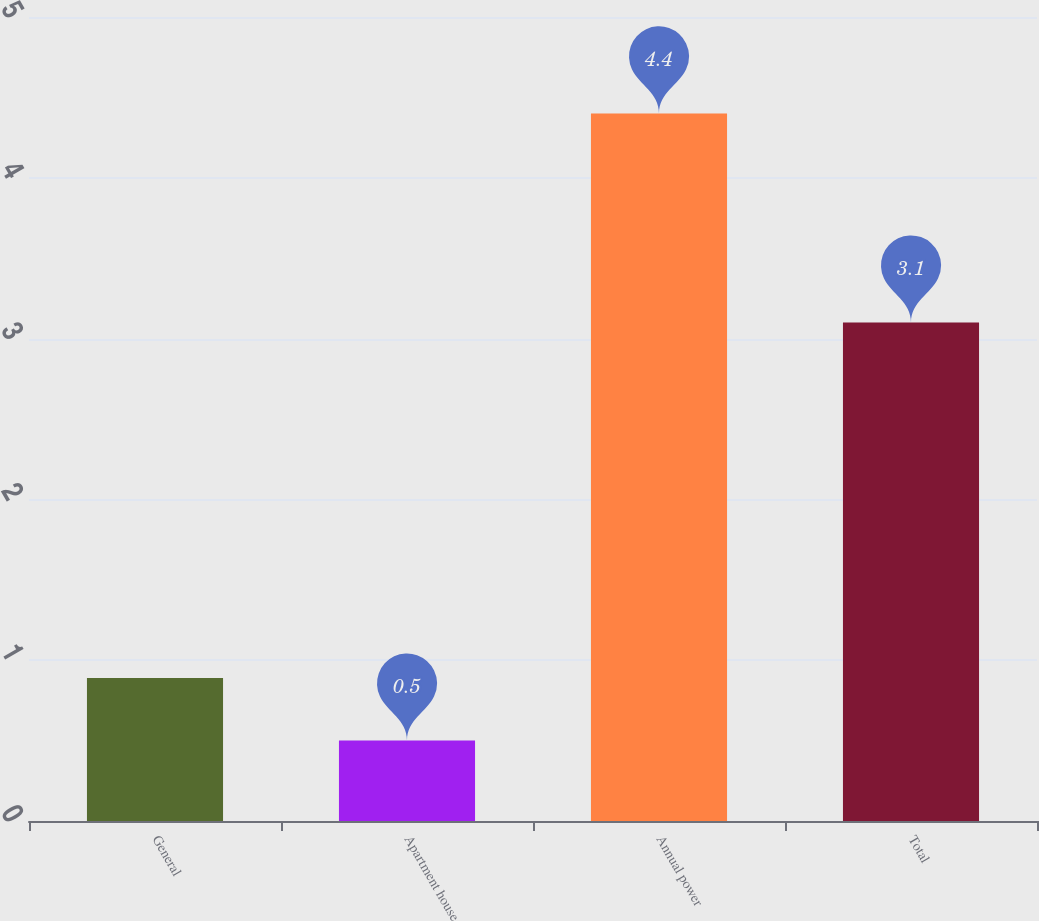Convert chart. <chart><loc_0><loc_0><loc_500><loc_500><bar_chart><fcel>General<fcel>Apartment house<fcel>Annual power<fcel>Total<nl><fcel>0.89<fcel>0.5<fcel>4.4<fcel>3.1<nl></chart> 